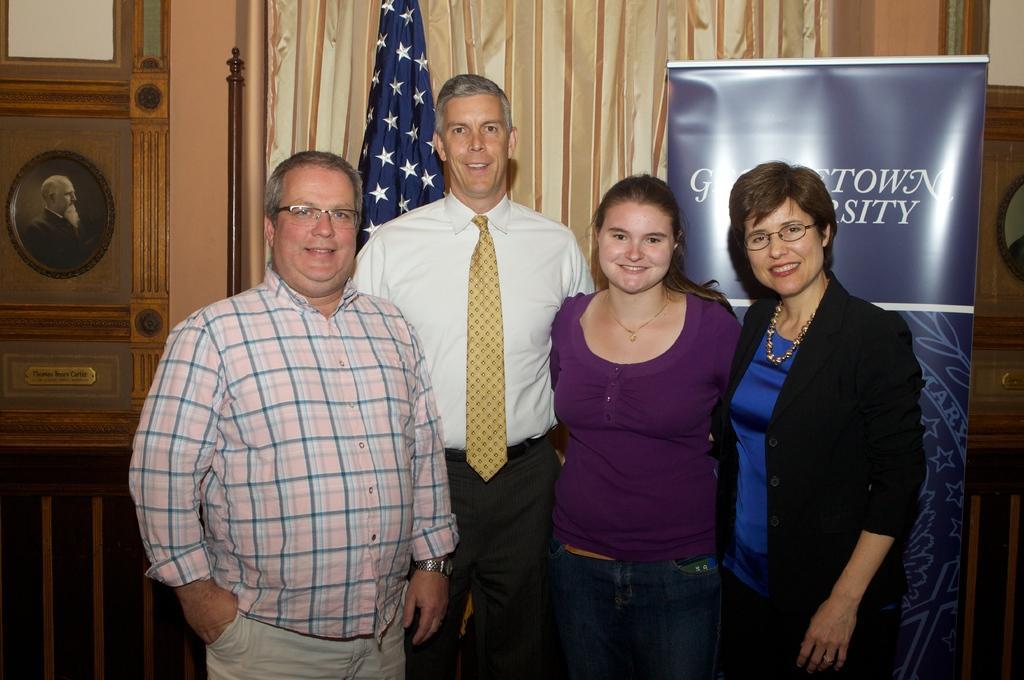Describe this image in one or two sentences. This picture is clicked inside. In the center we can see the group of two women and two men standing on the ground and smiling. In the background we can see the curtain, a flag, pole, picture frame hanging on the wall and a blue color banner on which the text is printed. 